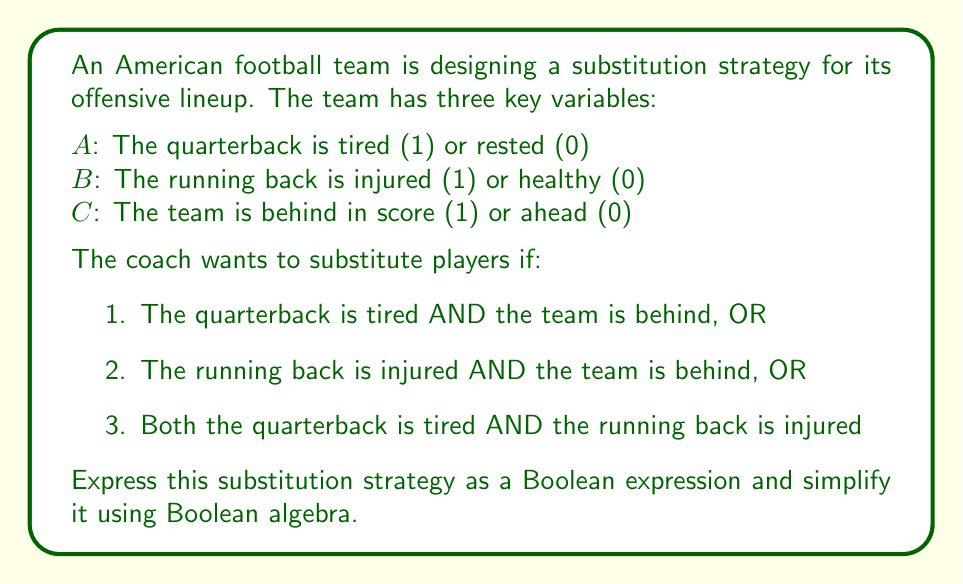What is the answer to this math problem? Let's approach this step-by-step:

1) First, we'll express each condition as a Boolean expression:
   Condition 1: $A \cdot C$
   Condition 2: $B \cdot C$
   Condition 3: $A \cdot B$

2) The overall expression is the OR of these three conditions:
   $F = (A \cdot C) + (B \cdot C) + (A \cdot B)$

3) We can simplify this using the distributive law:
   $F = C \cdot (A + B) + (A \cdot B)$

4) Now, let's apply the absorption law: $X + (X \cdot Y) = X$
   Here, $C \cdot (A + B)$ is our $X$ and $(A \cdot B)$ is our $(X \cdot Y)$
   
   $F = C \cdot (A + B)$

5) This simplified expression means: substitute if the team is behind AND either the quarterback is tired OR the running back is injured.

This optimization reduces the number of terms in the Boolean expression, potentially simplifying the decision-making process for substitutions during the game.
Answer: $C \cdot (A + B)$ 